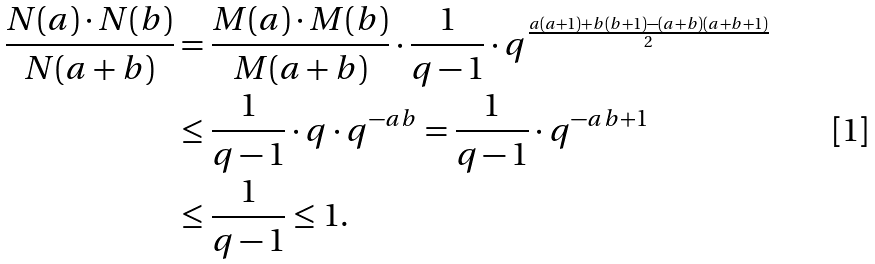Convert formula to latex. <formula><loc_0><loc_0><loc_500><loc_500>\frac { N ( a ) \cdot N ( b ) } { N ( a + b ) } & = \frac { M ( a ) \cdot M ( b ) } { M ( a + b ) } \cdot \frac { 1 } { q - 1 } \cdot q ^ { \frac { a ( a + 1 ) + b ( b + 1 ) - ( a + b ) ( a + b + 1 ) } { 2 } } \\ & \leq \frac { 1 } { q - 1 } \cdot q \cdot q ^ { - a b } = \frac { 1 } { q - 1 } \cdot q ^ { - a b + 1 } \\ & \leq \frac { 1 } { q - 1 } \leq 1 . \\</formula> 